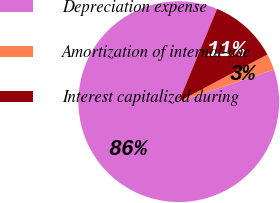Convert chart to OTSL. <chart><loc_0><loc_0><loc_500><loc_500><pie_chart><fcel>Depreciation expense<fcel>Amortization of internal-use<fcel>Interest capitalized during<nl><fcel>86.41%<fcel>2.61%<fcel>10.99%<nl></chart> 